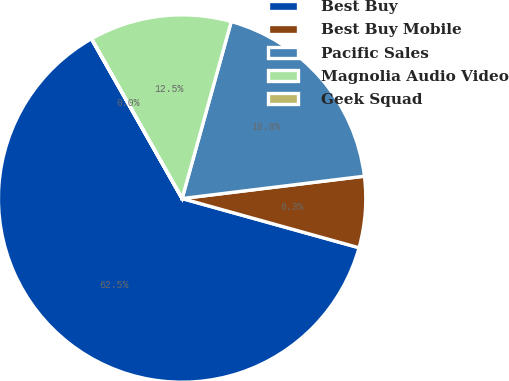<chart> <loc_0><loc_0><loc_500><loc_500><pie_chart><fcel>Best Buy<fcel>Best Buy Mobile<fcel>Pacific Sales<fcel>Magnolia Audio Video<fcel>Geek Squad<nl><fcel>62.46%<fcel>6.26%<fcel>18.75%<fcel>12.51%<fcel>0.02%<nl></chart> 